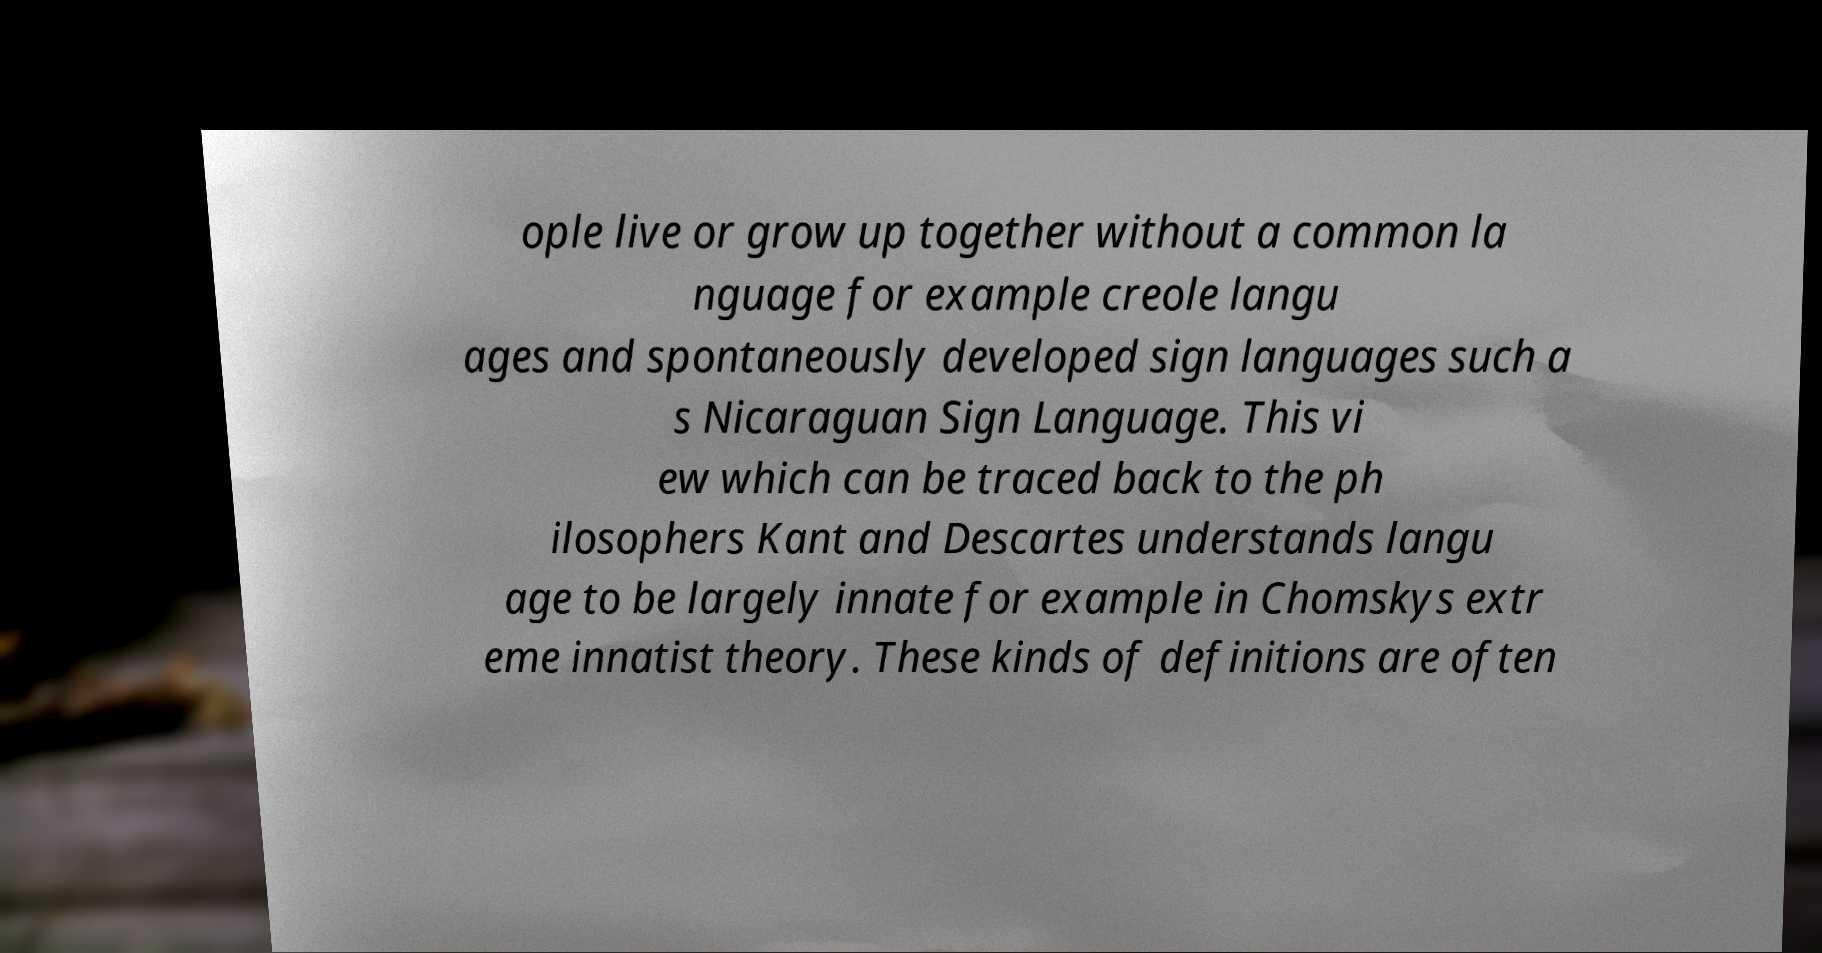What messages or text are displayed in this image? I need them in a readable, typed format. ople live or grow up together without a common la nguage for example creole langu ages and spontaneously developed sign languages such a s Nicaraguan Sign Language. This vi ew which can be traced back to the ph ilosophers Kant and Descartes understands langu age to be largely innate for example in Chomskys extr eme innatist theory. These kinds of definitions are often 